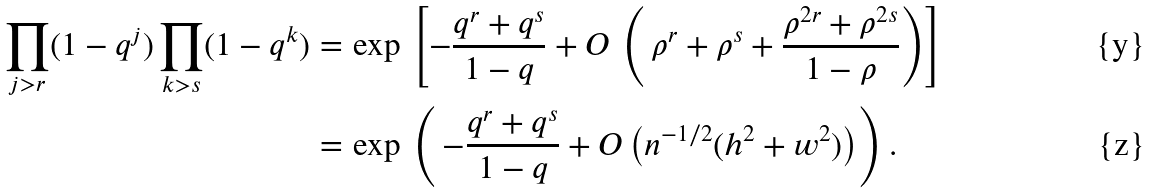<formula> <loc_0><loc_0><loc_500><loc_500>\prod _ { j > r } ( 1 - q ^ { j } ) \prod _ { k > s } ( 1 - q ^ { k } ) = & \, \exp \, \left [ - \frac { q ^ { r } + q ^ { s } } { 1 - q } + O \, \left ( \, \rho ^ { r } + \rho ^ { s } + \frac { \rho ^ { 2 r } + \rho ^ { 2 s } } { 1 - \rho } \right ) \right ] \\ = & \, \exp \, \left ( \, - \frac { q ^ { r } + q ^ { s } } { 1 - q } + O \left ( n ^ { - 1 / 2 } ( h ^ { 2 } + w ^ { 2 } ) \right ) \right ) .</formula> 